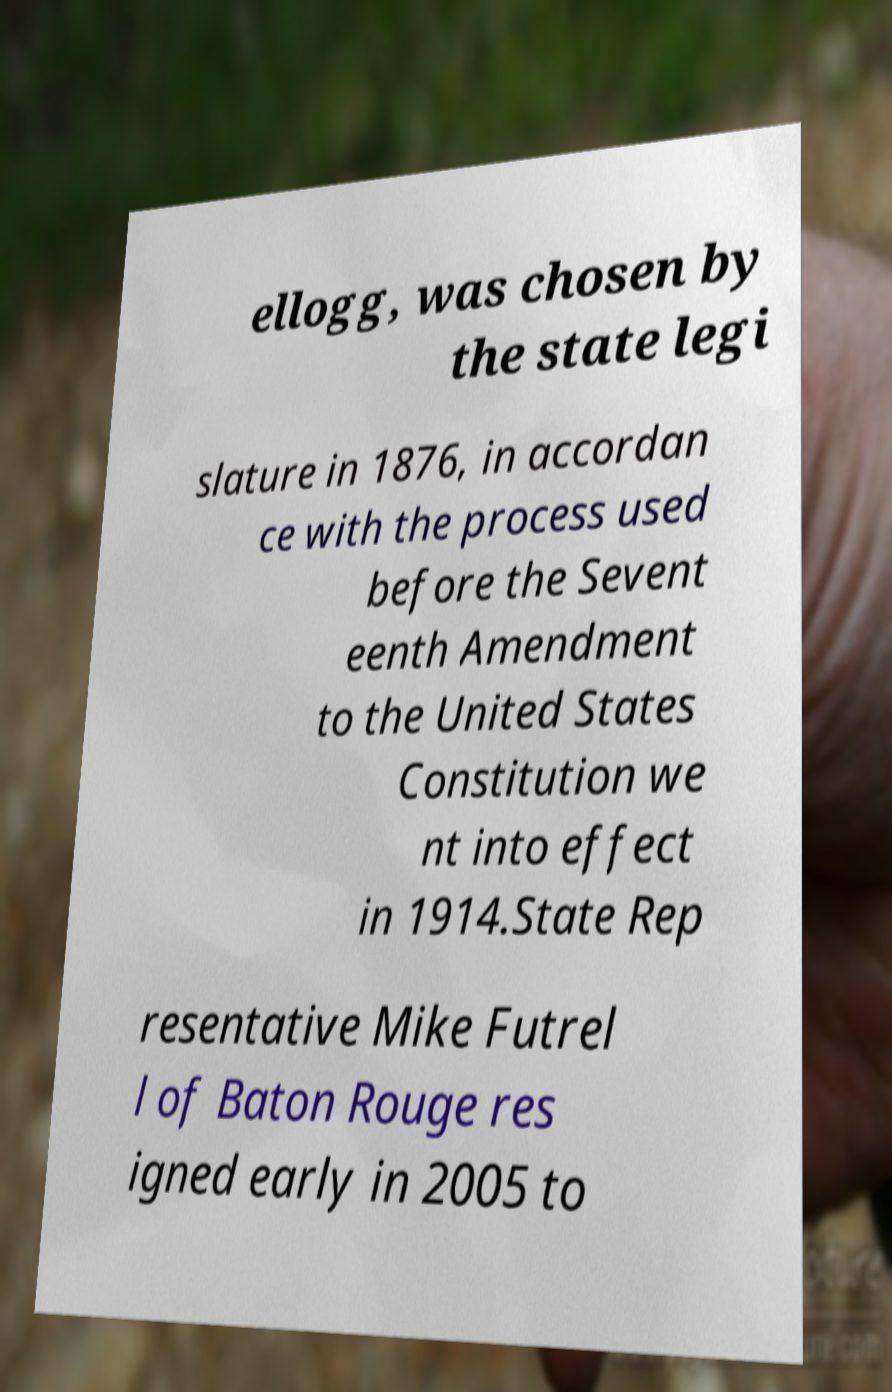Can you accurately transcribe the text from the provided image for me? ellogg, was chosen by the state legi slature in 1876, in accordan ce with the process used before the Sevent eenth Amendment to the United States Constitution we nt into effect in 1914.State Rep resentative Mike Futrel l of Baton Rouge res igned early in 2005 to 